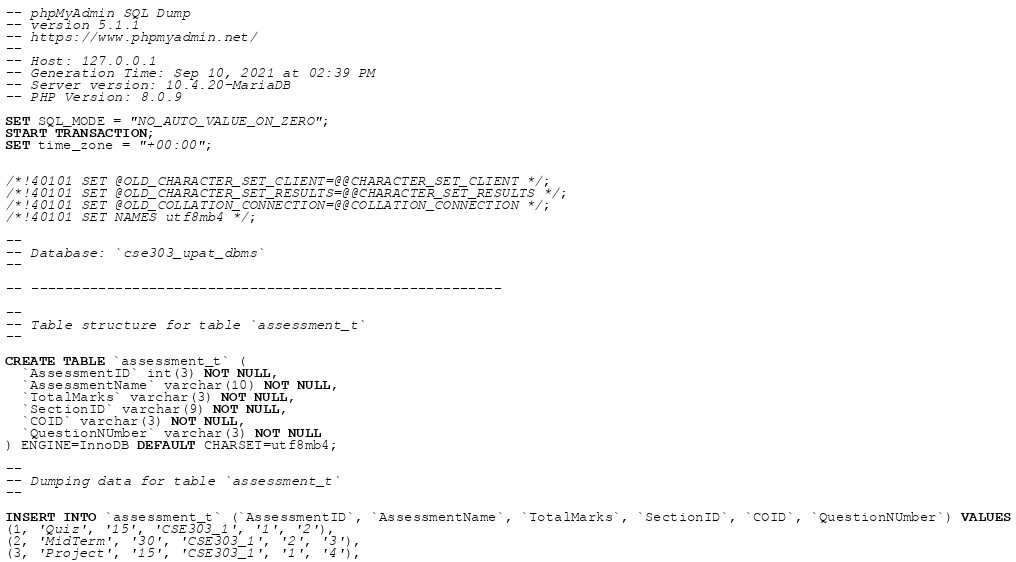<code> <loc_0><loc_0><loc_500><loc_500><_SQL_>-- phpMyAdmin SQL Dump
-- version 5.1.1
-- https://www.phpmyadmin.net/
--
-- Host: 127.0.0.1
-- Generation Time: Sep 10, 2021 at 02:39 PM
-- Server version: 10.4.20-MariaDB
-- PHP Version: 8.0.9

SET SQL_MODE = "NO_AUTO_VALUE_ON_ZERO";
START TRANSACTION;
SET time_zone = "+00:00";


/*!40101 SET @OLD_CHARACTER_SET_CLIENT=@@CHARACTER_SET_CLIENT */;
/*!40101 SET @OLD_CHARACTER_SET_RESULTS=@@CHARACTER_SET_RESULTS */;
/*!40101 SET @OLD_COLLATION_CONNECTION=@@COLLATION_CONNECTION */;
/*!40101 SET NAMES utf8mb4 */;

--
-- Database: `cse303_upat_dbms`
--

-- --------------------------------------------------------

--
-- Table structure for table `assessment_t`
--

CREATE TABLE `assessment_t` (
  `AssessmentID` int(3) NOT NULL,
  `AssessmentName` varchar(10) NOT NULL,
  `TotalMarks` varchar(3) NOT NULL,
  `SectionID` varchar(9) NOT NULL,
  `COID` varchar(3) NOT NULL,
  `QuestionNUmber` varchar(3) NOT NULL
) ENGINE=InnoDB DEFAULT CHARSET=utf8mb4;

--
-- Dumping data for table `assessment_t`
--

INSERT INTO `assessment_t` (`AssessmentID`, `AssessmentName`, `TotalMarks`, `SectionID`, `COID`, `QuestionNUmber`) VALUES
(1, 'Quiz', '15', 'CSE303_1', '1', '2'),
(2, 'MidTerm', '30', 'CSE303_1', '2', '3'),
(3, 'Project', '15', 'CSE303_1', '1', '4'),</code> 